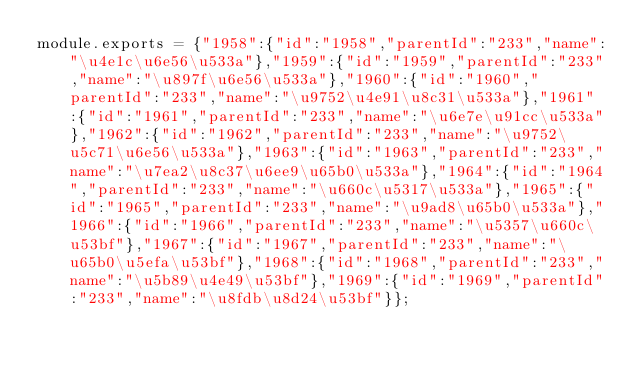Convert code to text. <code><loc_0><loc_0><loc_500><loc_500><_JavaScript_>module.exports = {"1958":{"id":"1958","parentId":"233","name":"\u4e1c\u6e56\u533a"},"1959":{"id":"1959","parentId":"233","name":"\u897f\u6e56\u533a"},"1960":{"id":"1960","parentId":"233","name":"\u9752\u4e91\u8c31\u533a"},"1961":{"id":"1961","parentId":"233","name":"\u6e7e\u91cc\u533a"},"1962":{"id":"1962","parentId":"233","name":"\u9752\u5c71\u6e56\u533a"},"1963":{"id":"1963","parentId":"233","name":"\u7ea2\u8c37\u6ee9\u65b0\u533a"},"1964":{"id":"1964","parentId":"233","name":"\u660c\u5317\u533a"},"1965":{"id":"1965","parentId":"233","name":"\u9ad8\u65b0\u533a"},"1966":{"id":"1966","parentId":"233","name":"\u5357\u660c\u53bf"},"1967":{"id":"1967","parentId":"233","name":"\u65b0\u5efa\u53bf"},"1968":{"id":"1968","parentId":"233","name":"\u5b89\u4e49\u53bf"},"1969":{"id":"1969","parentId":"233","name":"\u8fdb\u8d24\u53bf"}};</code> 